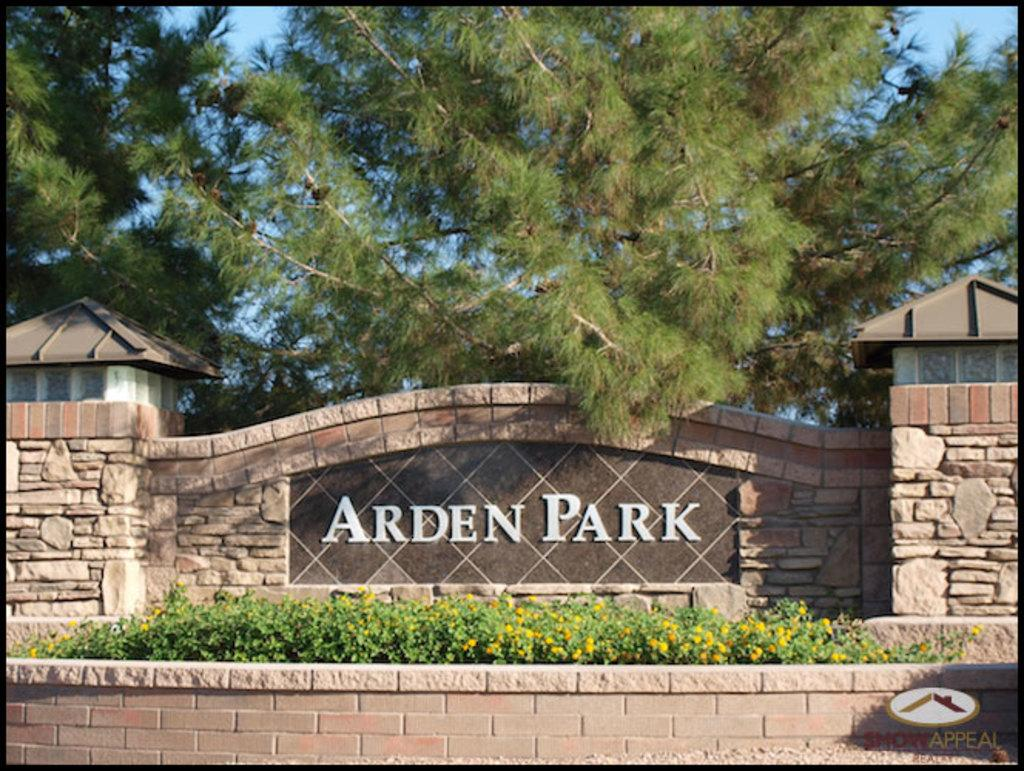What is written or depicted on the wall in the image? There is a wall with text in the image. What structures are located on both sides of the wall? There are sheds on both sides of the wall. What type of plants can be seen in front of the wall? There are plants with flowers in front of the wall. What can be seen in the background of the image? There are trees and the sky visible in the background of the image. Can you see any mice running around in the image? There are no mice present in the image. Is there a tiger hiding behind the sheds in the image? There is no tiger present in the image. 